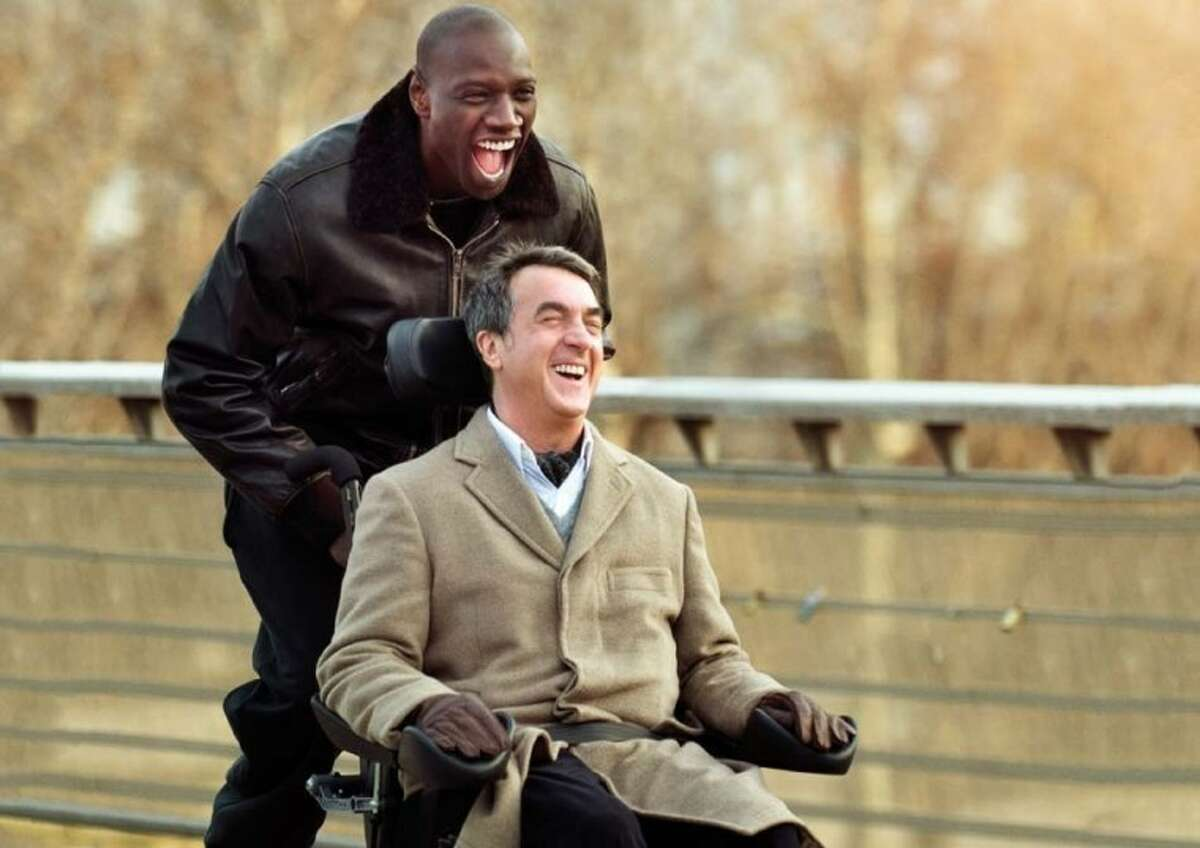Can you describe the main features of this image for me? This image captures a deeply joyful and heartwarming moment from the film 'The Intouchables.' Here, Fran\u00e7ois Cluzet, who is in a wheelchair, exhibits an expression of pure delight, wearing a stylish beige coat paired with a scarf. Alongside him stands Omar Sy, who is similarly overwhelmed with joy, dressed in a chic black leather jacket. They are enjoying a vibrant moment on a bridge, which is framed by a backdrop of bare trees, hinting at a cool weather setting. This scene not only showcases a pivotal moment of companionship in the film but also subtly portrays the themes of friendship and overcoming adversity. 